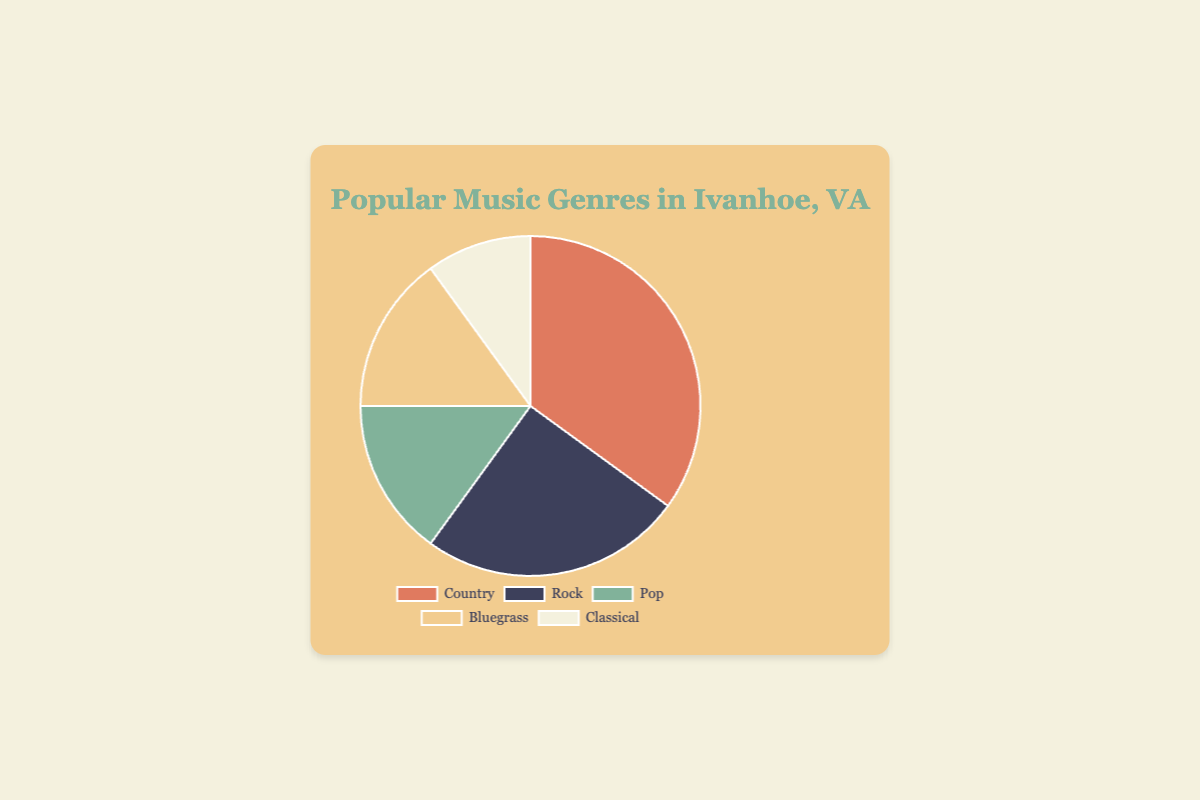Which music genre is the most popular among Ivanhoe residents? From the pie chart, it's clear that the largest segment is devoted to the Country genre, which is 35%.
Answer: Country What is the combined percentage of residents who prefer Pop and Bluegrass music? The percentages for Pop and Bluegrass are 15% and 15%, respectively. Adding them together gives 15% + 15% = 30%.
Answer: 30% Which genre is less popular: Classical or Pop? By comparing the size of the segments for Classical and Pop, we see that Classical has 10% and Pop has 15%. Since 10% is less than 15%, Classical is less popular.
Answer: Classical Is Rock music more popular than Pop music? By comparing the segments, Rock has 25% and Pop has 15%. Since 25% is greater than 15%, Rock is indeed more popular than Pop.
Answer: Yes What is the difference in popularity between Country and Rock music? The pie chart shows that Country has 35% and Rock has 25%. The difference is calculated as 35% - 25% = 10%.
Answer: 10% What color represents Bluegrass in the pie chart? The segment for Bluegrass is colored in yellow (or 'f2cc8f' in code)
Answer: Yellow Which two genres are equally popular? The segments for Pop and Bluegrass are both 15%, indicating they are equally popular.
Answer: Pop and Bluegrass How much more popular is the most popular genre compared to the least popular genre? The most popular genre is Country at 35%, and the least popular genre is Classical at 10%. The difference is 35% - 10% = 25%.
Answer: 25% What fraction of residents prefer either Country or Rock music? The percentage for Country is 35% and for Rock, it is 25%. The sum is 35% + 25% = 60%, which translates to the fraction 60/100. Simplified, it is 3/5.
Answer: 3/5 What is the average percentage for all the music genres? To find the average, add all the percentages: 35% + 25% + 15% + 15% + 10% = 100%. Then divide by the number of genres: 100% / 5 = 20%
Answer: 20% 